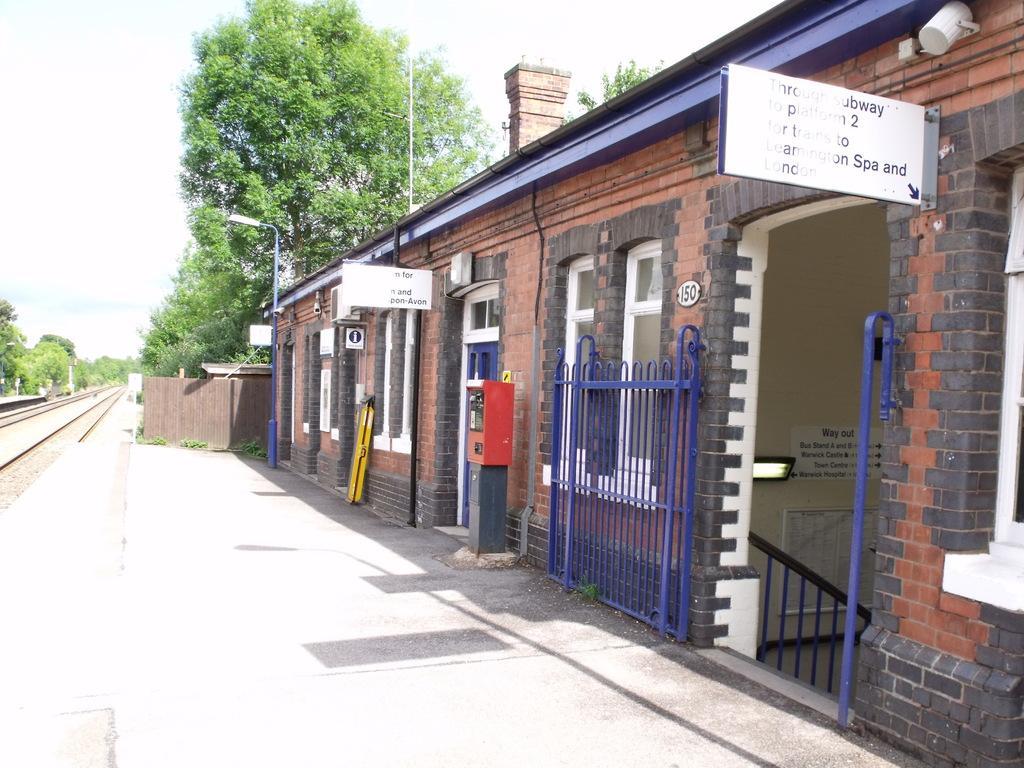How would you summarize this image in a sentence or two? In this image I can see walls, boards, grille, railing, posters, light, windows, door, light pole, train track and objects. 